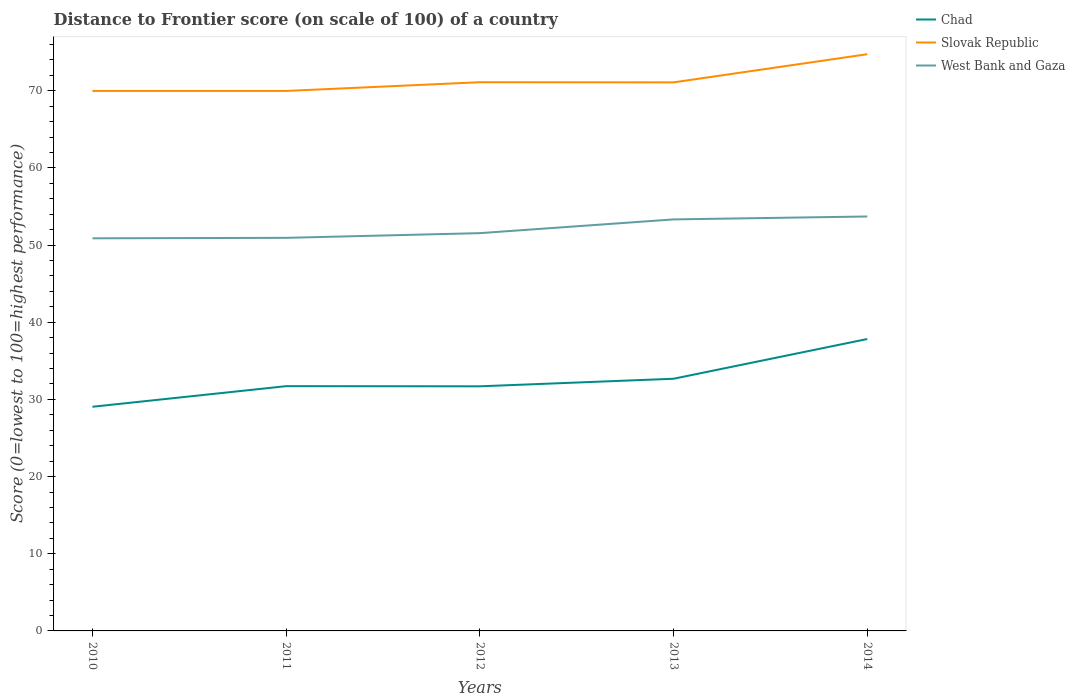Does the line corresponding to Chad intersect with the line corresponding to West Bank and Gaza?
Make the answer very short. No. Across all years, what is the maximum distance to frontier score of in Slovak Republic?
Your response must be concise. 69.98. What is the total distance to frontier score of in Slovak Republic in the graph?
Offer a terse response. 0.02. What is the difference between the highest and the second highest distance to frontier score of in Chad?
Offer a terse response. 8.78. Is the distance to frontier score of in Chad strictly greater than the distance to frontier score of in Slovak Republic over the years?
Ensure brevity in your answer.  Yes. How many lines are there?
Provide a short and direct response. 3. How many years are there in the graph?
Provide a short and direct response. 5. Are the values on the major ticks of Y-axis written in scientific E-notation?
Provide a short and direct response. No. Does the graph contain any zero values?
Your response must be concise. No. How many legend labels are there?
Provide a short and direct response. 3. What is the title of the graph?
Your answer should be very brief. Distance to Frontier score (on scale of 100) of a country. Does "Djibouti" appear as one of the legend labels in the graph?
Provide a succinct answer. No. What is the label or title of the X-axis?
Your answer should be compact. Years. What is the label or title of the Y-axis?
Make the answer very short. Score (0=lowest to 100=highest performance). What is the Score (0=lowest to 100=highest performance) in Chad in 2010?
Your response must be concise. 29.05. What is the Score (0=lowest to 100=highest performance) of Slovak Republic in 2010?
Your answer should be very brief. 69.98. What is the Score (0=lowest to 100=highest performance) in West Bank and Gaza in 2010?
Make the answer very short. 50.88. What is the Score (0=lowest to 100=highest performance) in Chad in 2011?
Your answer should be very brief. 31.72. What is the Score (0=lowest to 100=highest performance) of Slovak Republic in 2011?
Your answer should be compact. 69.98. What is the Score (0=lowest to 100=highest performance) of West Bank and Gaza in 2011?
Give a very brief answer. 50.94. What is the Score (0=lowest to 100=highest performance) of Chad in 2012?
Your response must be concise. 31.7. What is the Score (0=lowest to 100=highest performance) of Slovak Republic in 2012?
Make the answer very short. 71.11. What is the Score (0=lowest to 100=highest performance) of West Bank and Gaza in 2012?
Ensure brevity in your answer.  51.55. What is the Score (0=lowest to 100=highest performance) of Chad in 2013?
Ensure brevity in your answer.  32.68. What is the Score (0=lowest to 100=highest performance) of Slovak Republic in 2013?
Make the answer very short. 71.09. What is the Score (0=lowest to 100=highest performance) in West Bank and Gaza in 2013?
Ensure brevity in your answer.  53.33. What is the Score (0=lowest to 100=highest performance) in Chad in 2014?
Keep it short and to the point. 37.83. What is the Score (0=lowest to 100=highest performance) of Slovak Republic in 2014?
Offer a terse response. 74.74. What is the Score (0=lowest to 100=highest performance) in West Bank and Gaza in 2014?
Provide a short and direct response. 53.71. Across all years, what is the maximum Score (0=lowest to 100=highest performance) of Chad?
Provide a succinct answer. 37.83. Across all years, what is the maximum Score (0=lowest to 100=highest performance) of Slovak Republic?
Your answer should be compact. 74.74. Across all years, what is the maximum Score (0=lowest to 100=highest performance) in West Bank and Gaza?
Your answer should be compact. 53.71. Across all years, what is the minimum Score (0=lowest to 100=highest performance) of Chad?
Give a very brief answer. 29.05. Across all years, what is the minimum Score (0=lowest to 100=highest performance) of Slovak Republic?
Your answer should be compact. 69.98. Across all years, what is the minimum Score (0=lowest to 100=highest performance) of West Bank and Gaza?
Provide a short and direct response. 50.88. What is the total Score (0=lowest to 100=highest performance) of Chad in the graph?
Keep it short and to the point. 162.98. What is the total Score (0=lowest to 100=highest performance) in Slovak Republic in the graph?
Your response must be concise. 356.9. What is the total Score (0=lowest to 100=highest performance) in West Bank and Gaza in the graph?
Ensure brevity in your answer.  260.41. What is the difference between the Score (0=lowest to 100=highest performance) of Chad in 2010 and that in 2011?
Make the answer very short. -2.67. What is the difference between the Score (0=lowest to 100=highest performance) of Slovak Republic in 2010 and that in 2011?
Keep it short and to the point. 0. What is the difference between the Score (0=lowest to 100=highest performance) of West Bank and Gaza in 2010 and that in 2011?
Offer a very short reply. -0.06. What is the difference between the Score (0=lowest to 100=highest performance) of Chad in 2010 and that in 2012?
Ensure brevity in your answer.  -2.65. What is the difference between the Score (0=lowest to 100=highest performance) of Slovak Republic in 2010 and that in 2012?
Your response must be concise. -1.13. What is the difference between the Score (0=lowest to 100=highest performance) of West Bank and Gaza in 2010 and that in 2012?
Your answer should be very brief. -0.67. What is the difference between the Score (0=lowest to 100=highest performance) in Chad in 2010 and that in 2013?
Ensure brevity in your answer.  -3.63. What is the difference between the Score (0=lowest to 100=highest performance) in Slovak Republic in 2010 and that in 2013?
Your answer should be compact. -1.11. What is the difference between the Score (0=lowest to 100=highest performance) of West Bank and Gaza in 2010 and that in 2013?
Provide a succinct answer. -2.45. What is the difference between the Score (0=lowest to 100=highest performance) in Chad in 2010 and that in 2014?
Your answer should be compact. -8.78. What is the difference between the Score (0=lowest to 100=highest performance) of Slovak Republic in 2010 and that in 2014?
Keep it short and to the point. -4.76. What is the difference between the Score (0=lowest to 100=highest performance) in West Bank and Gaza in 2010 and that in 2014?
Your response must be concise. -2.83. What is the difference between the Score (0=lowest to 100=highest performance) of Chad in 2011 and that in 2012?
Provide a succinct answer. 0.02. What is the difference between the Score (0=lowest to 100=highest performance) of Slovak Republic in 2011 and that in 2012?
Your answer should be very brief. -1.13. What is the difference between the Score (0=lowest to 100=highest performance) of West Bank and Gaza in 2011 and that in 2012?
Ensure brevity in your answer.  -0.61. What is the difference between the Score (0=lowest to 100=highest performance) in Chad in 2011 and that in 2013?
Your response must be concise. -0.96. What is the difference between the Score (0=lowest to 100=highest performance) of Slovak Republic in 2011 and that in 2013?
Your answer should be compact. -1.11. What is the difference between the Score (0=lowest to 100=highest performance) of West Bank and Gaza in 2011 and that in 2013?
Offer a very short reply. -2.39. What is the difference between the Score (0=lowest to 100=highest performance) in Chad in 2011 and that in 2014?
Give a very brief answer. -6.11. What is the difference between the Score (0=lowest to 100=highest performance) in Slovak Republic in 2011 and that in 2014?
Ensure brevity in your answer.  -4.76. What is the difference between the Score (0=lowest to 100=highest performance) of West Bank and Gaza in 2011 and that in 2014?
Ensure brevity in your answer.  -2.77. What is the difference between the Score (0=lowest to 100=highest performance) in Chad in 2012 and that in 2013?
Your answer should be very brief. -0.98. What is the difference between the Score (0=lowest to 100=highest performance) in Slovak Republic in 2012 and that in 2013?
Give a very brief answer. 0.02. What is the difference between the Score (0=lowest to 100=highest performance) in West Bank and Gaza in 2012 and that in 2013?
Your response must be concise. -1.78. What is the difference between the Score (0=lowest to 100=highest performance) in Chad in 2012 and that in 2014?
Provide a succinct answer. -6.13. What is the difference between the Score (0=lowest to 100=highest performance) of Slovak Republic in 2012 and that in 2014?
Your answer should be very brief. -3.63. What is the difference between the Score (0=lowest to 100=highest performance) of West Bank and Gaza in 2012 and that in 2014?
Your answer should be compact. -2.16. What is the difference between the Score (0=lowest to 100=highest performance) in Chad in 2013 and that in 2014?
Give a very brief answer. -5.15. What is the difference between the Score (0=lowest to 100=highest performance) in Slovak Republic in 2013 and that in 2014?
Your answer should be compact. -3.65. What is the difference between the Score (0=lowest to 100=highest performance) in West Bank and Gaza in 2013 and that in 2014?
Your answer should be very brief. -0.38. What is the difference between the Score (0=lowest to 100=highest performance) of Chad in 2010 and the Score (0=lowest to 100=highest performance) of Slovak Republic in 2011?
Your response must be concise. -40.93. What is the difference between the Score (0=lowest to 100=highest performance) in Chad in 2010 and the Score (0=lowest to 100=highest performance) in West Bank and Gaza in 2011?
Provide a short and direct response. -21.89. What is the difference between the Score (0=lowest to 100=highest performance) in Slovak Republic in 2010 and the Score (0=lowest to 100=highest performance) in West Bank and Gaza in 2011?
Offer a very short reply. 19.04. What is the difference between the Score (0=lowest to 100=highest performance) of Chad in 2010 and the Score (0=lowest to 100=highest performance) of Slovak Republic in 2012?
Give a very brief answer. -42.06. What is the difference between the Score (0=lowest to 100=highest performance) in Chad in 2010 and the Score (0=lowest to 100=highest performance) in West Bank and Gaza in 2012?
Keep it short and to the point. -22.5. What is the difference between the Score (0=lowest to 100=highest performance) of Slovak Republic in 2010 and the Score (0=lowest to 100=highest performance) of West Bank and Gaza in 2012?
Ensure brevity in your answer.  18.43. What is the difference between the Score (0=lowest to 100=highest performance) of Chad in 2010 and the Score (0=lowest to 100=highest performance) of Slovak Republic in 2013?
Provide a succinct answer. -42.04. What is the difference between the Score (0=lowest to 100=highest performance) of Chad in 2010 and the Score (0=lowest to 100=highest performance) of West Bank and Gaza in 2013?
Your response must be concise. -24.28. What is the difference between the Score (0=lowest to 100=highest performance) in Slovak Republic in 2010 and the Score (0=lowest to 100=highest performance) in West Bank and Gaza in 2013?
Your answer should be very brief. 16.65. What is the difference between the Score (0=lowest to 100=highest performance) of Chad in 2010 and the Score (0=lowest to 100=highest performance) of Slovak Republic in 2014?
Provide a succinct answer. -45.69. What is the difference between the Score (0=lowest to 100=highest performance) of Chad in 2010 and the Score (0=lowest to 100=highest performance) of West Bank and Gaza in 2014?
Give a very brief answer. -24.66. What is the difference between the Score (0=lowest to 100=highest performance) in Slovak Republic in 2010 and the Score (0=lowest to 100=highest performance) in West Bank and Gaza in 2014?
Make the answer very short. 16.27. What is the difference between the Score (0=lowest to 100=highest performance) of Chad in 2011 and the Score (0=lowest to 100=highest performance) of Slovak Republic in 2012?
Give a very brief answer. -39.39. What is the difference between the Score (0=lowest to 100=highest performance) in Chad in 2011 and the Score (0=lowest to 100=highest performance) in West Bank and Gaza in 2012?
Your answer should be very brief. -19.83. What is the difference between the Score (0=lowest to 100=highest performance) of Slovak Republic in 2011 and the Score (0=lowest to 100=highest performance) of West Bank and Gaza in 2012?
Keep it short and to the point. 18.43. What is the difference between the Score (0=lowest to 100=highest performance) of Chad in 2011 and the Score (0=lowest to 100=highest performance) of Slovak Republic in 2013?
Your answer should be compact. -39.37. What is the difference between the Score (0=lowest to 100=highest performance) in Chad in 2011 and the Score (0=lowest to 100=highest performance) in West Bank and Gaza in 2013?
Provide a short and direct response. -21.61. What is the difference between the Score (0=lowest to 100=highest performance) in Slovak Republic in 2011 and the Score (0=lowest to 100=highest performance) in West Bank and Gaza in 2013?
Give a very brief answer. 16.65. What is the difference between the Score (0=lowest to 100=highest performance) in Chad in 2011 and the Score (0=lowest to 100=highest performance) in Slovak Republic in 2014?
Your answer should be compact. -43.02. What is the difference between the Score (0=lowest to 100=highest performance) in Chad in 2011 and the Score (0=lowest to 100=highest performance) in West Bank and Gaza in 2014?
Offer a terse response. -21.99. What is the difference between the Score (0=lowest to 100=highest performance) of Slovak Republic in 2011 and the Score (0=lowest to 100=highest performance) of West Bank and Gaza in 2014?
Keep it short and to the point. 16.27. What is the difference between the Score (0=lowest to 100=highest performance) in Chad in 2012 and the Score (0=lowest to 100=highest performance) in Slovak Republic in 2013?
Your answer should be very brief. -39.39. What is the difference between the Score (0=lowest to 100=highest performance) in Chad in 2012 and the Score (0=lowest to 100=highest performance) in West Bank and Gaza in 2013?
Provide a short and direct response. -21.63. What is the difference between the Score (0=lowest to 100=highest performance) in Slovak Republic in 2012 and the Score (0=lowest to 100=highest performance) in West Bank and Gaza in 2013?
Give a very brief answer. 17.78. What is the difference between the Score (0=lowest to 100=highest performance) of Chad in 2012 and the Score (0=lowest to 100=highest performance) of Slovak Republic in 2014?
Your response must be concise. -43.04. What is the difference between the Score (0=lowest to 100=highest performance) in Chad in 2012 and the Score (0=lowest to 100=highest performance) in West Bank and Gaza in 2014?
Your answer should be very brief. -22.01. What is the difference between the Score (0=lowest to 100=highest performance) of Chad in 2013 and the Score (0=lowest to 100=highest performance) of Slovak Republic in 2014?
Your answer should be compact. -42.06. What is the difference between the Score (0=lowest to 100=highest performance) in Chad in 2013 and the Score (0=lowest to 100=highest performance) in West Bank and Gaza in 2014?
Your answer should be very brief. -21.03. What is the difference between the Score (0=lowest to 100=highest performance) in Slovak Republic in 2013 and the Score (0=lowest to 100=highest performance) in West Bank and Gaza in 2014?
Make the answer very short. 17.38. What is the average Score (0=lowest to 100=highest performance) in Chad per year?
Give a very brief answer. 32.6. What is the average Score (0=lowest to 100=highest performance) in Slovak Republic per year?
Offer a terse response. 71.38. What is the average Score (0=lowest to 100=highest performance) of West Bank and Gaza per year?
Your answer should be compact. 52.08. In the year 2010, what is the difference between the Score (0=lowest to 100=highest performance) in Chad and Score (0=lowest to 100=highest performance) in Slovak Republic?
Your answer should be very brief. -40.93. In the year 2010, what is the difference between the Score (0=lowest to 100=highest performance) of Chad and Score (0=lowest to 100=highest performance) of West Bank and Gaza?
Keep it short and to the point. -21.83. In the year 2011, what is the difference between the Score (0=lowest to 100=highest performance) of Chad and Score (0=lowest to 100=highest performance) of Slovak Republic?
Make the answer very short. -38.26. In the year 2011, what is the difference between the Score (0=lowest to 100=highest performance) of Chad and Score (0=lowest to 100=highest performance) of West Bank and Gaza?
Offer a terse response. -19.22. In the year 2011, what is the difference between the Score (0=lowest to 100=highest performance) in Slovak Republic and Score (0=lowest to 100=highest performance) in West Bank and Gaza?
Give a very brief answer. 19.04. In the year 2012, what is the difference between the Score (0=lowest to 100=highest performance) in Chad and Score (0=lowest to 100=highest performance) in Slovak Republic?
Offer a terse response. -39.41. In the year 2012, what is the difference between the Score (0=lowest to 100=highest performance) of Chad and Score (0=lowest to 100=highest performance) of West Bank and Gaza?
Your answer should be very brief. -19.85. In the year 2012, what is the difference between the Score (0=lowest to 100=highest performance) in Slovak Republic and Score (0=lowest to 100=highest performance) in West Bank and Gaza?
Make the answer very short. 19.56. In the year 2013, what is the difference between the Score (0=lowest to 100=highest performance) of Chad and Score (0=lowest to 100=highest performance) of Slovak Republic?
Offer a terse response. -38.41. In the year 2013, what is the difference between the Score (0=lowest to 100=highest performance) of Chad and Score (0=lowest to 100=highest performance) of West Bank and Gaza?
Offer a terse response. -20.65. In the year 2013, what is the difference between the Score (0=lowest to 100=highest performance) in Slovak Republic and Score (0=lowest to 100=highest performance) in West Bank and Gaza?
Make the answer very short. 17.76. In the year 2014, what is the difference between the Score (0=lowest to 100=highest performance) of Chad and Score (0=lowest to 100=highest performance) of Slovak Republic?
Offer a terse response. -36.91. In the year 2014, what is the difference between the Score (0=lowest to 100=highest performance) in Chad and Score (0=lowest to 100=highest performance) in West Bank and Gaza?
Ensure brevity in your answer.  -15.88. In the year 2014, what is the difference between the Score (0=lowest to 100=highest performance) in Slovak Republic and Score (0=lowest to 100=highest performance) in West Bank and Gaza?
Your answer should be compact. 21.03. What is the ratio of the Score (0=lowest to 100=highest performance) of Chad in 2010 to that in 2011?
Provide a succinct answer. 0.92. What is the ratio of the Score (0=lowest to 100=highest performance) in West Bank and Gaza in 2010 to that in 2011?
Keep it short and to the point. 1. What is the ratio of the Score (0=lowest to 100=highest performance) in Chad in 2010 to that in 2012?
Give a very brief answer. 0.92. What is the ratio of the Score (0=lowest to 100=highest performance) in Slovak Republic in 2010 to that in 2012?
Give a very brief answer. 0.98. What is the ratio of the Score (0=lowest to 100=highest performance) in Slovak Republic in 2010 to that in 2013?
Offer a terse response. 0.98. What is the ratio of the Score (0=lowest to 100=highest performance) of West Bank and Gaza in 2010 to that in 2013?
Ensure brevity in your answer.  0.95. What is the ratio of the Score (0=lowest to 100=highest performance) in Chad in 2010 to that in 2014?
Your answer should be compact. 0.77. What is the ratio of the Score (0=lowest to 100=highest performance) in Slovak Republic in 2010 to that in 2014?
Offer a terse response. 0.94. What is the ratio of the Score (0=lowest to 100=highest performance) in West Bank and Gaza in 2010 to that in 2014?
Your answer should be very brief. 0.95. What is the ratio of the Score (0=lowest to 100=highest performance) of Chad in 2011 to that in 2012?
Provide a succinct answer. 1. What is the ratio of the Score (0=lowest to 100=highest performance) in Slovak Republic in 2011 to that in 2012?
Offer a terse response. 0.98. What is the ratio of the Score (0=lowest to 100=highest performance) in West Bank and Gaza in 2011 to that in 2012?
Make the answer very short. 0.99. What is the ratio of the Score (0=lowest to 100=highest performance) in Chad in 2011 to that in 2013?
Your answer should be compact. 0.97. What is the ratio of the Score (0=lowest to 100=highest performance) in Slovak Republic in 2011 to that in 2013?
Provide a short and direct response. 0.98. What is the ratio of the Score (0=lowest to 100=highest performance) in West Bank and Gaza in 2011 to that in 2013?
Make the answer very short. 0.96. What is the ratio of the Score (0=lowest to 100=highest performance) of Chad in 2011 to that in 2014?
Your response must be concise. 0.84. What is the ratio of the Score (0=lowest to 100=highest performance) in Slovak Republic in 2011 to that in 2014?
Provide a short and direct response. 0.94. What is the ratio of the Score (0=lowest to 100=highest performance) of West Bank and Gaza in 2011 to that in 2014?
Ensure brevity in your answer.  0.95. What is the ratio of the Score (0=lowest to 100=highest performance) in Chad in 2012 to that in 2013?
Offer a terse response. 0.97. What is the ratio of the Score (0=lowest to 100=highest performance) of Slovak Republic in 2012 to that in 2013?
Keep it short and to the point. 1. What is the ratio of the Score (0=lowest to 100=highest performance) in West Bank and Gaza in 2012 to that in 2013?
Your answer should be compact. 0.97. What is the ratio of the Score (0=lowest to 100=highest performance) in Chad in 2012 to that in 2014?
Your answer should be compact. 0.84. What is the ratio of the Score (0=lowest to 100=highest performance) of Slovak Republic in 2012 to that in 2014?
Keep it short and to the point. 0.95. What is the ratio of the Score (0=lowest to 100=highest performance) of West Bank and Gaza in 2012 to that in 2014?
Give a very brief answer. 0.96. What is the ratio of the Score (0=lowest to 100=highest performance) of Chad in 2013 to that in 2014?
Provide a succinct answer. 0.86. What is the ratio of the Score (0=lowest to 100=highest performance) of Slovak Republic in 2013 to that in 2014?
Give a very brief answer. 0.95. What is the difference between the highest and the second highest Score (0=lowest to 100=highest performance) in Chad?
Offer a very short reply. 5.15. What is the difference between the highest and the second highest Score (0=lowest to 100=highest performance) of Slovak Republic?
Your response must be concise. 3.63. What is the difference between the highest and the second highest Score (0=lowest to 100=highest performance) of West Bank and Gaza?
Your response must be concise. 0.38. What is the difference between the highest and the lowest Score (0=lowest to 100=highest performance) of Chad?
Provide a succinct answer. 8.78. What is the difference between the highest and the lowest Score (0=lowest to 100=highest performance) of Slovak Republic?
Give a very brief answer. 4.76. What is the difference between the highest and the lowest Score (0=lowest to 100=highest performance) of West Bank and Gaza?
Offer a very short reply. 2.83. 